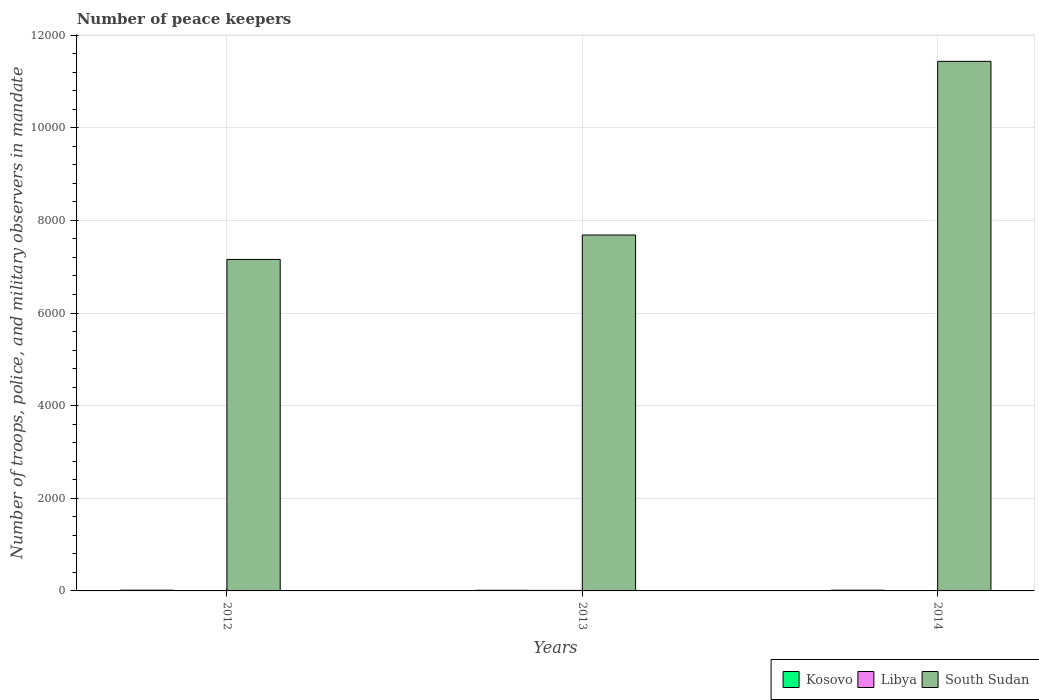How many different coloured bars are there?
Give a very brief answer. 3. Are the number of bars on each tick of the X-axis equal?
Your response must be concise. Yes. How many bars are there on the 2nd tick from the left?
Provide a succinct answer. 3. Across all years, what is the maximum number of peace keepers in in Libya?
Give a very brief answer. 11. What is the total number of peace keepers in in Libya in the graph?
Make the answer very short. 15. What is the difference between the number of peace keepers in in Libya in 2012 and that in 2014?
Keep it short and to the point. 0. What is the difference between the number of peace keepers in in Libya in 2014 and the number of peace keepers in in South Sudan in 2012?
Your response must be concise. -7155. What is the average number of peace keepers in in Libya per year?
Offer a terse response. 5. In the year 2013, what is the difference between the number of peace keepers in in Kosovo and number of peace keepers in in Libya?
Ensure brevity in your answer.  3. Is the number of peace keepers in in Kosovo in 2012 less than that in 2014?
Provide a short and direct response. No. What does the 2nd bar from the left in 2012 represents?
Your answer should be very brief. Libya. What does the 2nd bar from the right in 2012 represents?
Ensure brevity in your answer.  Libya. Is it the case that in every year, the sum of the number of peace keepers in in South Sudan and number of peace keepers in in Kosovo is greater than the number of peace keepers in in Libya?
Offer a very short reply. Yes. Are all the bars in the graph horizontal?
Give a very brief answer. No. How many years are there in the graph?
Offer a terse response. 3. What is the difference between two consecutive major ticks on the Y-axis?
Provide a succinct answer. 2000. Does the graph contain any zero values?
Ensure brevity in your answer.  No. What is the title of the graph?
Give a very brief answer. Number of peace keepers. Does "High income: OECD" appear as one of the legend labels in the graph?
Offer a terse response. No. What is the label or title of the Y-axis?
Provide a short and direct response. Number of troops, police, and military observers in mandate. What is the Number of troops, police, and military observers in mandate in Kosovo in 2012?
Your answer should be compact. 16. What is the Number of troops, police, and military observers in mandate of Libya in 2012?
Give a very brief answer. 2. What is the Number of troops, police, and military observers in mandate in South Sudan in 2012?
Offer a very short reply. 7157. What is the Number of troops, police, and military observers in mandate in Kosovo in 2013?
Offer a very short reply. 14. What is the Number of troops, police, and military observers in mandate of South Sudan in 2013?
Your answer should be very brief. 7684. What is the Number of troops, police, and military observers in mandate in South Sudan in 2014?
Offer a terse response. 1.14e+04. Across all years, what is the maximum Number of troops, police, and military observers in mandate in South Sudan?
Offer a terse response. 1.14e+04. Across all years, what is the minimum Number of troops, police, and military observers in mandate of Libya?
Your response must be concise. 2. Across all years, what is the minimum Number of troops, police, and military observers in mandate of South Sudan?
Give a very brief answer. 7157. What is the total Number of troops, police, and military observers in mandate of Kosovo in the graph?
Keep it short and to the point. 46. What is the total Number of troops, police, and military observers in mandate of South Sudan in the graph?
Provide a short and direct response. 2.63e+04. What is the difference between the Number of troops, police, and military observers in mandate of Kosovo in 2012 and that in 2013?
Provide a short and direct response. 2. What is the difference between the Number of troops, police, and military observers in mandate of Libya in 2012 and that in 2013?
Your answer should be compact. -9. What is the difference between the Number of troops, police, and military observers in mandate in South Sudan in 2012 and that in 2013?
Offer a very short reply. -527. What is the difference between the Number of troops, police, and military observers in mandate of Kosovo in 2012 and that in 2014?
Keep it short and to the point. 0. What is the difference between the Number of troops, police, and military observers in mandate in South Sudan in 2012 and that in 2014?
Ensure brevity in your answer.  -4276. What is the difference between the Number of troops, police, and military observers in mandate in Kosovo in 2013 and that in 2014?
Ensure brevity in your answer.  -2. What is the difference between the Number of troops, police, and military observers in mandate in South Sudan in 2013 and that in 2014?
Make the answer very short. -3749. What is the difference between the Number of troops, police, and military observers in mandate in Kosovo in 2012 and the Number of troops, police, and military observers in mandate in South Sudan in 2013?
Make the answer very short. -7668. What is the difference between the Number of troops, police, and military observers in mandate in Libya in 2012 and the Number of troops, police, and military observers in mandate in South Sudan in 2013?
Provide a succinct answer. -7682. What is the difference between the Number of troops, police, and military observers in mandate in Kosovo in 2012 and the Number of troops, police, and military observers in mandate in South Sudan in 2014?
Give a very brief answer. -1.14e+04. What is the difference between the Number of troops, police, and military observers in mandate in Libya in 2012 and the Number of troops, police, and military observers in mandate in South Sudan in 2014?
Keep it short and to the point. -1.14e+04. What is the difference between the Number of troops, police, and military observers in mandate in Kosovo in 2013 and the Number of troops, police, and military observers in mandate in South Sudan in 2014?
Ensure brevity in your answer.  -1.14e+04. What is the difference between the Number of troops, police, and military observers in mandate in Libya in 2013 and the Number of troops, police, and military observers in mandate in South Sudan in 2014?
Your answer should be very brief. -1.14e+04. What is the average Number of troops, police, and military observers in mandate in Kosovo per year?
Provide a short and direct response. 15.33. What is the average Number of troops, police, and military observers in mandate of Libya per year?
Provide a short and direct response. 5. What is the average Number of troops, police, and military observers in mandate of South Sudan per year?
Keep it short and to the point. 8758. In the year 2012, what is the difference between the Number of troops, police, and military observers in mandate in Kosovo and Number of troops, police, and military observers in mandate in South Sudan?
Provide a succinct answer. -7141. In the year 2012, what is the difference between the Number of troops, police, and military observers in mandate of Libya and Number of troops, police, and military observers in mandate of South Sudan?
Your answer should be very brief. -7155. In the year 2013, what is the difference between the Number of troops, police, and military observers in mandate of Kosovo and Number of troops, police, and military observers in mandate of Libya?
Your answer should be very brief. 3. In the year 2013, what is the difference between the Number of troops, police, and military observers in mandate of Kosovo and Number of troops, police, and military observers in mandate of South Sudan?
Keep it short and to the point. -7670. In the year 2013, what is the difference between the Number of troops, police, and military observers in mandate of Libya and Number of troops, police, and military observers in mandate of South Sudan?
Keep it short and to the point. -7673. In the year 2014, what is the difference between the Number of troops, police, and military observers in mandate of Kosovo and Number of troops, police, and military observers in mandate of Libya?
Offer a terse response. 14. In the year 2014, what is the difference between the Number of troops, police, and military observers in mandate in Kosovo and Number of troops, police, and military observers in mandate in South Sudan?
Offer a terse response. -1.14e+04. In the year 2014, what is the difference between the Number of troops, police, and military observers in mandate of Libya and Number of troops, police, and military observers in mandate of South Sudan?
Your answer should be very brief. -1.14e+04. What is the ratio of the Number of troops, police, and military observers in mandate in Kosovo in 2012 to that in 2013?
Make the answer very short. 1.14. What is the ratio of the Number of troops, police, and military observers in mandate in Libya in 2012 to that in 2013?
Your answer should be very brief. 0.18. What is the ratio of the Number of troops, police, and military observers in mandate of South Sudan in 2012 to that in 2013?
Your answer should be very brief. 0.93. What is the ratio of the Number of troops, police, and military observers in mandate of Libya in 2012 to that in 2014?
Ensure brevity in your answer.  1. What is the ratio of the Number of troops, police, and military observers in mandate of South Sudan in 2012 to that in 2014?
Provide a succinct answer. 0.63. What is the ratio of the Number of troops, police, and military observers in mandate of Kosovo in 2013 to that in 2014?
Your answer should be very brief. 0.88. What is the ratio of the Number of troops, police, and military observers in mandate in South Sudan in 2013 to that in 2014?
Offer a terse response. 0.67. What is the difference between the highest and the second highest Number of troops, police, and military observers in mandate of Kosovo?
Provide a short and direct response. 0. What is the difference between the highest and the second highest Number of troops, police, and military observers in mandate of South Sudan?
Your response must be concise. 3749. What is the difference between the highest and the lowest Number of troops, police, and military observers in mandate in South Sudan?
Keep it short and to the point. 4276. 